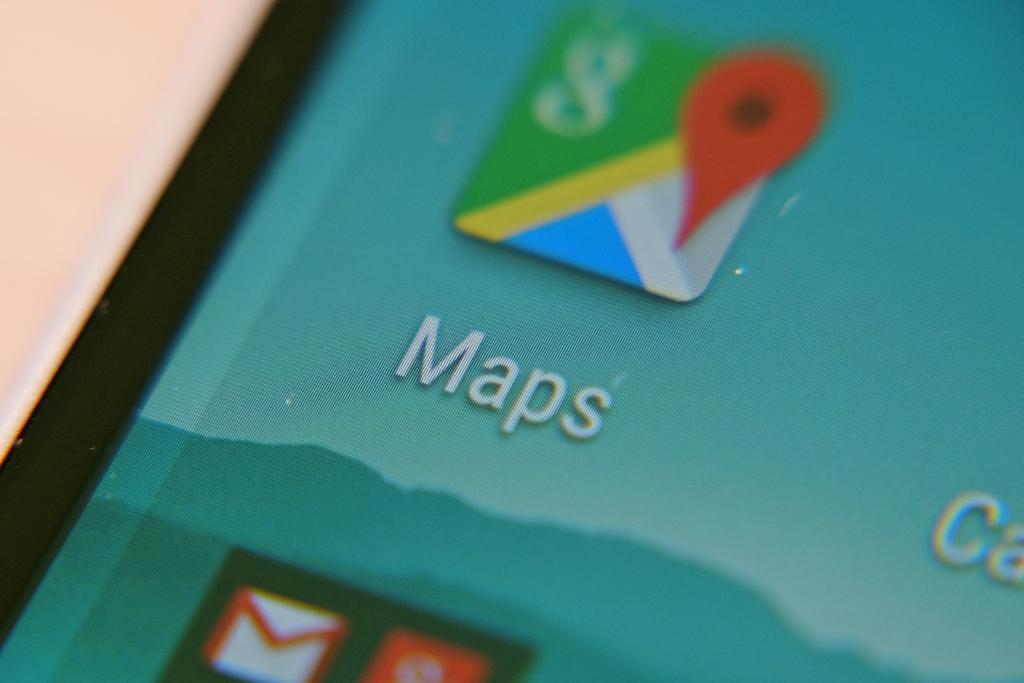Provide a one-sentence caption for the provided image. A smart phone with a smokey, blue mountain range in the background and the Maps app in the foreground. 